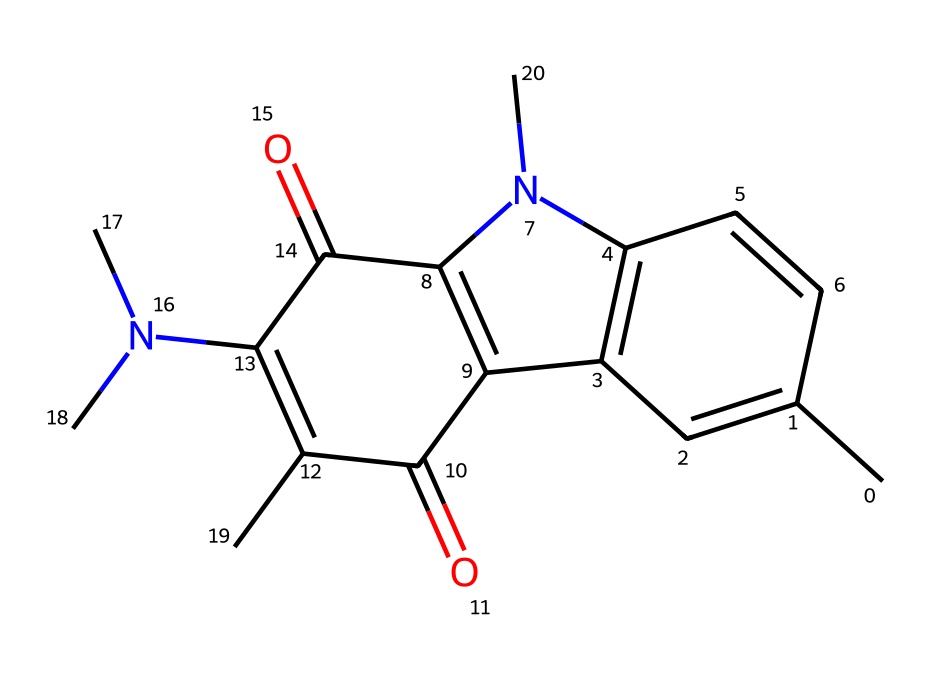What is the total number of carbon atoms in this compound? By examining the SMILES representation, we can identify the carbon atoms by counting every 'C'. The structure indicates a total of 15 carbon atoms.
Answer: 15 How many nitrogen atoms are present in this chemical? Looking at the SMILES, nitrogen is represented by 'N'. In this case, there are 2 occurrences of 'N', indicating 2 nitrogen atoms present.
Answer: 2 Is this compound a type of dye? The structure contains a conjugated system of alternating double bonds which is characteristic of dyes. Therefore, it is indeed classified as a dye.
Answer: Yes What type of functional group is present in the compound? The compound has carbonyl groups (C=O) and amine groups (N), which can be identified from the structure. Therefore, the functional groups present are carbonyl and amine groups.
Answer: carbonyl and amine What role do the light-sensitive dyes play in instant film photography? Light-sensitive dyes are crucial in photography as they react to light, enabling the formation of an image when exposed. This makes them essential for capturing photographs in instant film.
Answer: Image formation 